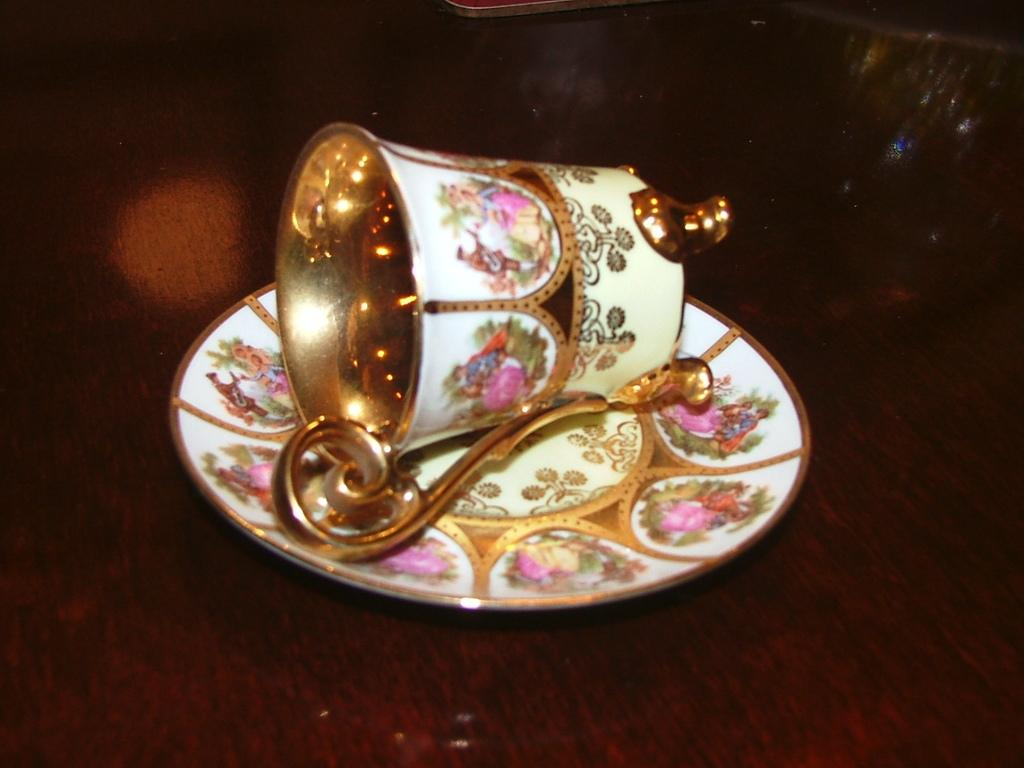What is present on the table in the image? There is a cup and a saucer in the image. How are the cup and saucer arranged on the table? The cup and saucer are placed on the table. What type of underwear is the person wearing in the image? There is no person present in the image, and therefore no underwear can be observed. 